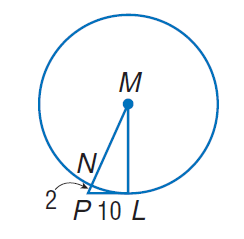Answer the mathemtical geometry problem and directly provide the correct option letter.
Question: Find the perimeter of the polygon for the given information.
Choices: A: 2 B: 10 C: 30 D: 60 D 